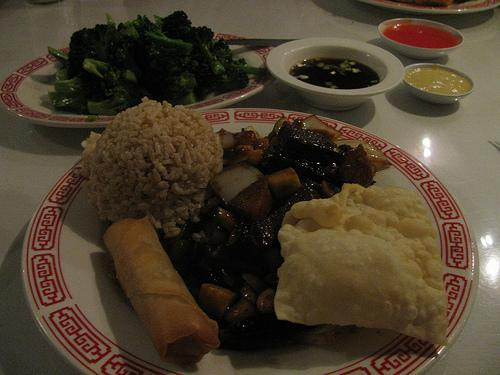Question: how many rolls are there?
Choices:
A. 12.
B. 13.
C. 5.
D. 1.
Answer with the letter. Answer: D Question: when was the picture taken?
Choices:
A. Breakfast.
B. Lunch time.
C. Snack time.
D. Dinner time.
Answer with the letter. Answer: D Question: what color is the rice?
Choices:
A. Teal.
B. Purple.
C. Brown.
D. Neon.
Answer with the letter. Answer: C 